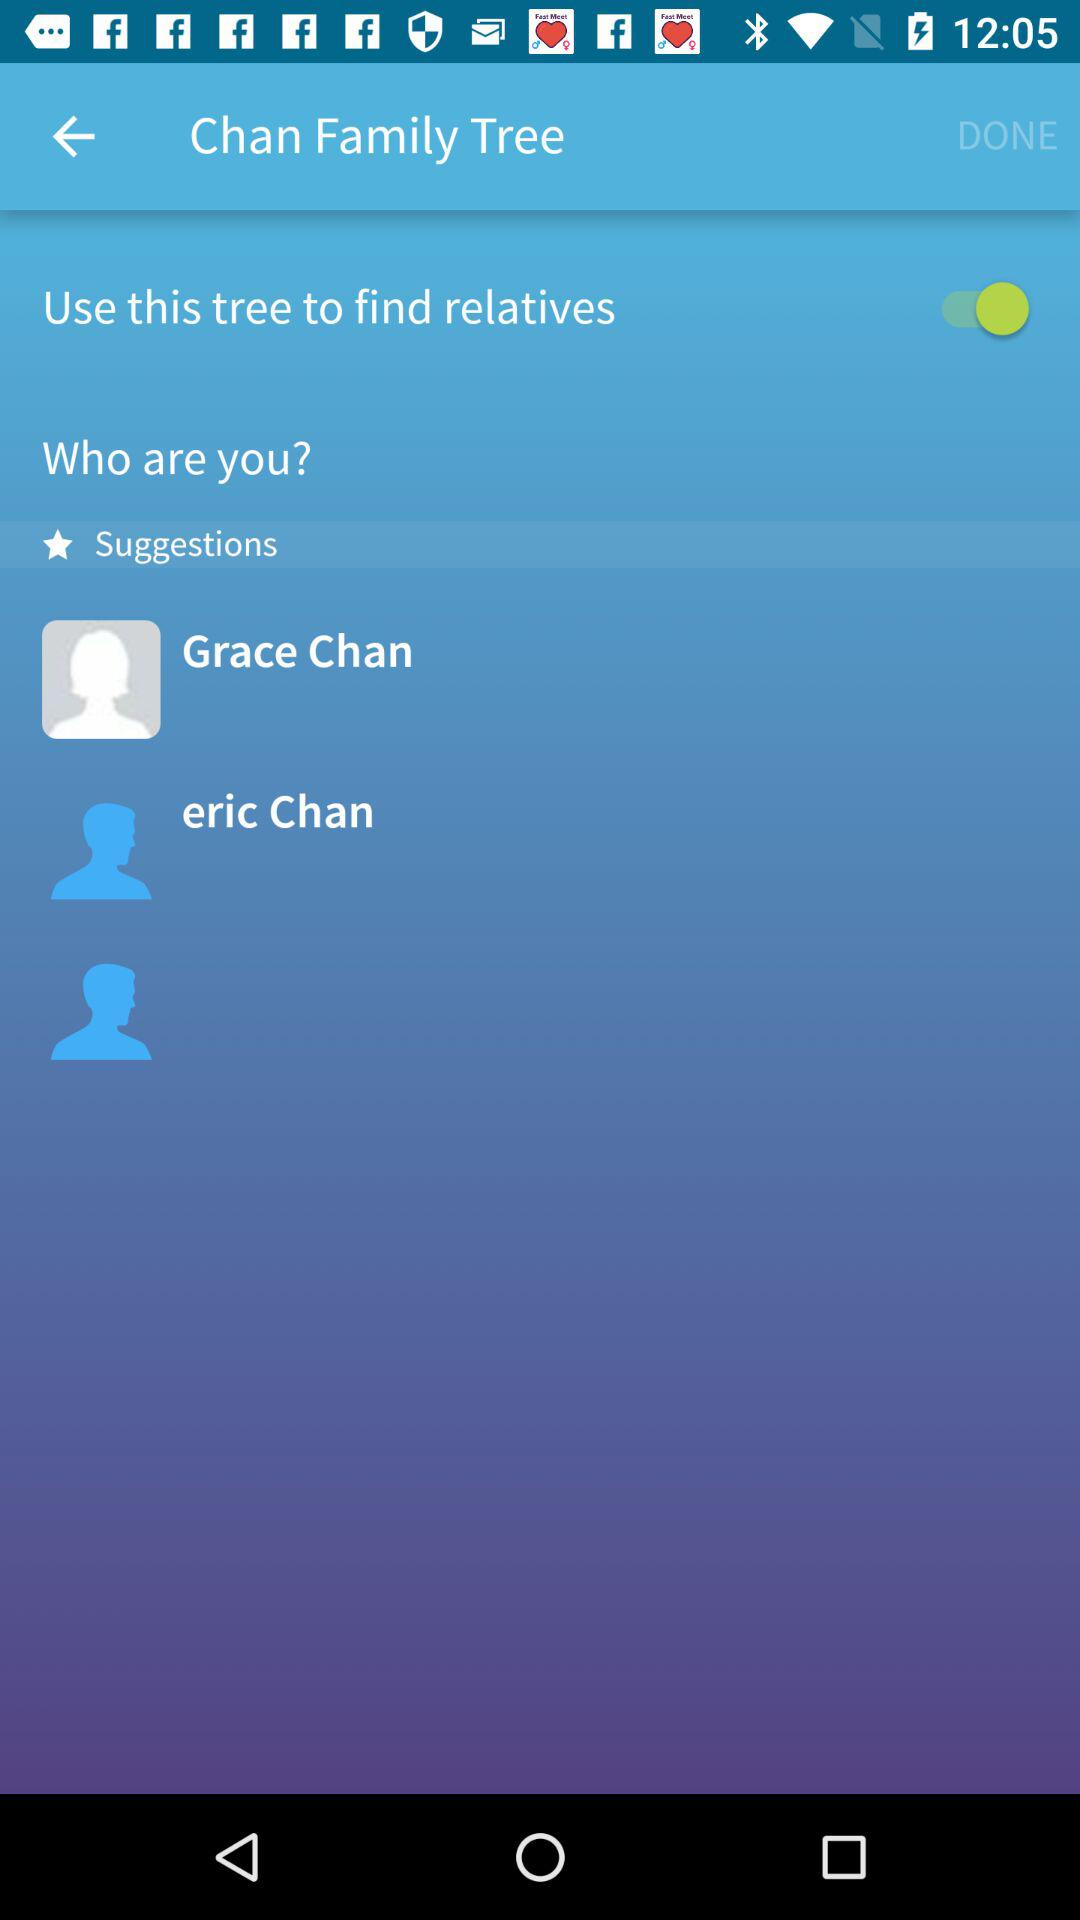How many suggestions are there?
Answer the question using a single word or phrase. 3 